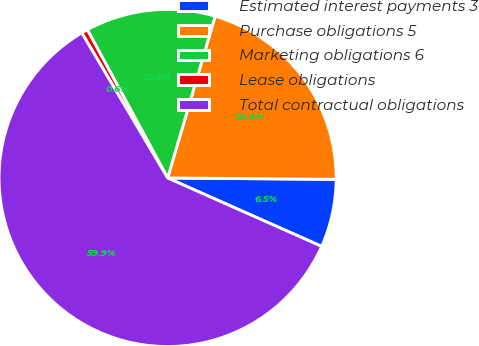Convert chart. <chart><loc_0><loc_0><loc_500><loc_500><pie_chart><fcel>Estimated interest payments 3<fcel>Purchase obligations 5<fcel>Marketing obligations 6<fcel>Lease obligations<fcel>Total contractual obligations<nl><fcel>6.52%<fcel>20.58%<fcel>12.45%<fcel>0.6%<fcel>59.85%<nl></chart> 